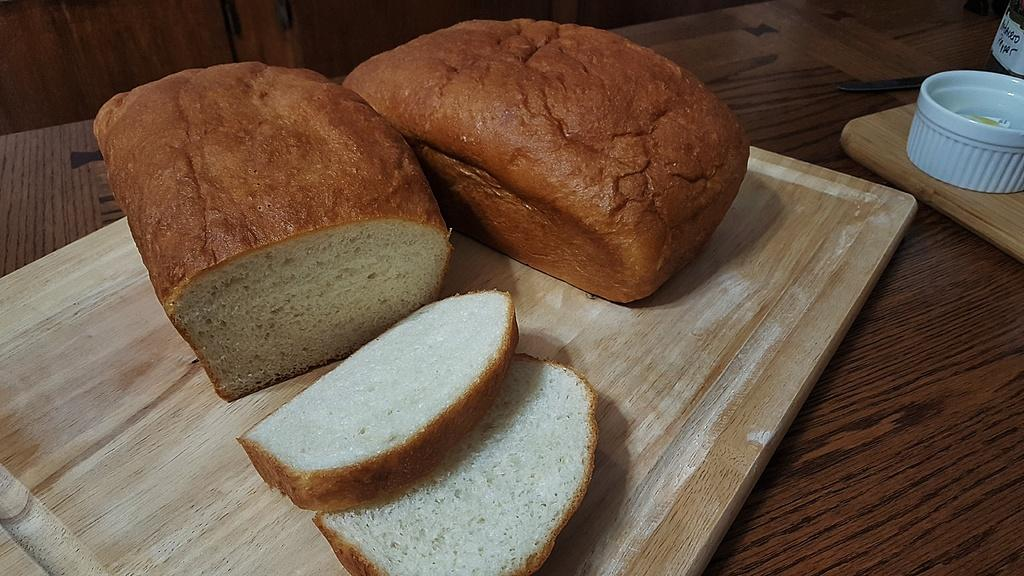What is located in the foreground of the picture? There are bread slices and bread in the foreground of the picture. What can be seen on the table in the image? There are wooden trays, a bowl, a knife, and a bottle on the table. How many items are on the table in the image? There are five items on the table: wooden trays, a bowl, a knife, and a bottle. How many rabbits are hopping around the table in the image? There are no rabbits present in the image; it only features bread, wooden trays, a bowl, a knife, and a bottle on the table. What color is the shirt worn by the person in the image? There is no person present in the image, so it is not possible to determine the color of a shirt. 